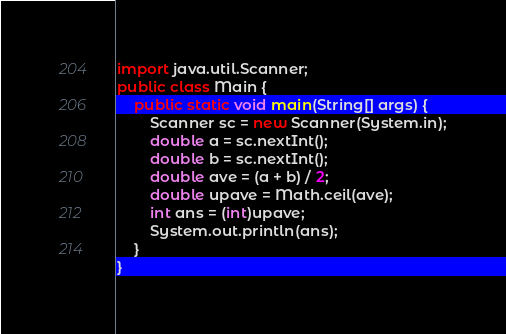<code> <loc_0><loc_0><loc_500><loc_500><_Java_>import java.util.Scanner;
public class Main {
	public static void main(String[] args) {
		Scanner sc = new Scanner(System.in);
		double a = sc.nextInt();
		double b = sc.nextInt();
		double ave = (a + b) / 2;
		double upave = Math.ceil(ave);
		int ans = (int)upave;
		System.out.println(ans);
	}
}</code> 